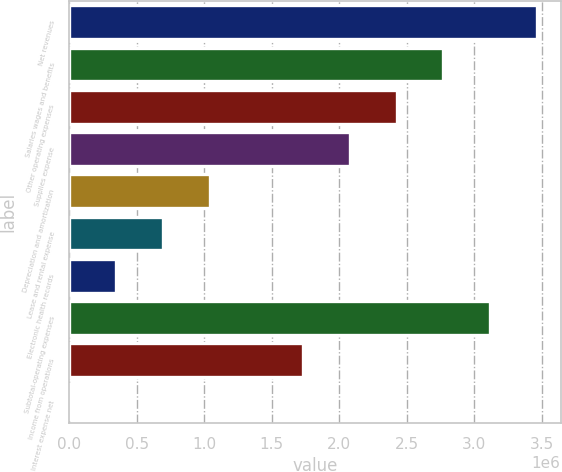Convert chart. <chart><loc_0><loc_0><loc_500><loc_500><bar_chart><fcel>Net revenues<fcel>Salaries wages and benefits<fcel>Other operating expenses<fcel>Supplies expense<fcel>Depreciation and amortization<fcel>Lease and rental expense<fcel>Electronic health records<fcel>Subtotal-operating expenses<fcel>Income from operations<fcel>Interest expense net<nl><fcel>3.46488e+06<fcel>2.7701e+06<fcel>2.42444e+06<fcel>2.07878e+06<fcel>1.0418e+06<fcel>696135<fcel>350475<fcel>3.11922e+06<fcel>1.73312e+06<fcel>4815<nl></chart> 